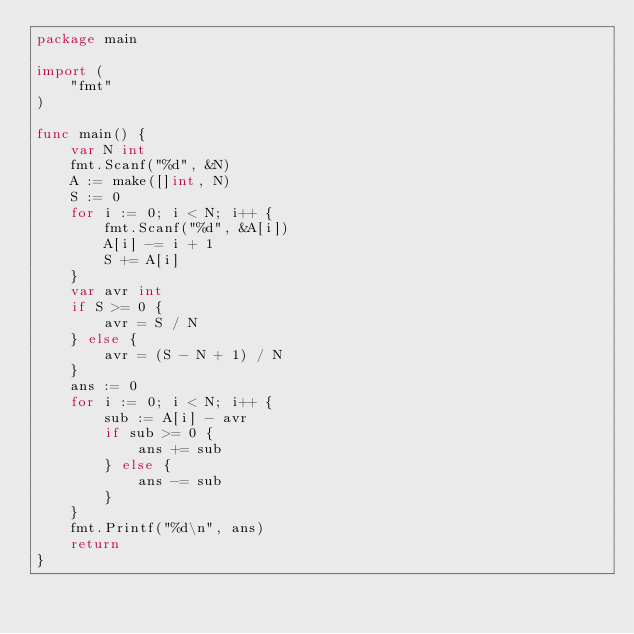<code> <loc_0><loc_0><loc_500><loc_500><_Go_>package main

import (
	"fmt"
)

func main() {
	var N int
	fmt.Scanf("%d", &N)
	A := make([]int, N)
	S := 0
	for i := 0; i < N; i++ {
		fmt.Scanf("%d", &A[i])
		A[i] -= i + 1
		S += A[i]
	}
	var avr int
	if S >= 0 {
		avr = S / N
	} else {
		avr = (S - N + 1) / N
	}
	ans := 0
	for i := 0; i < N; i++ {
		sub := A[i] - avr
		if sub >= 0 {
			ans += sub
		} else {
			ans -= sub
		}
	}
	fmt.Printf("%d\n", ans)
	return
}
</code> 